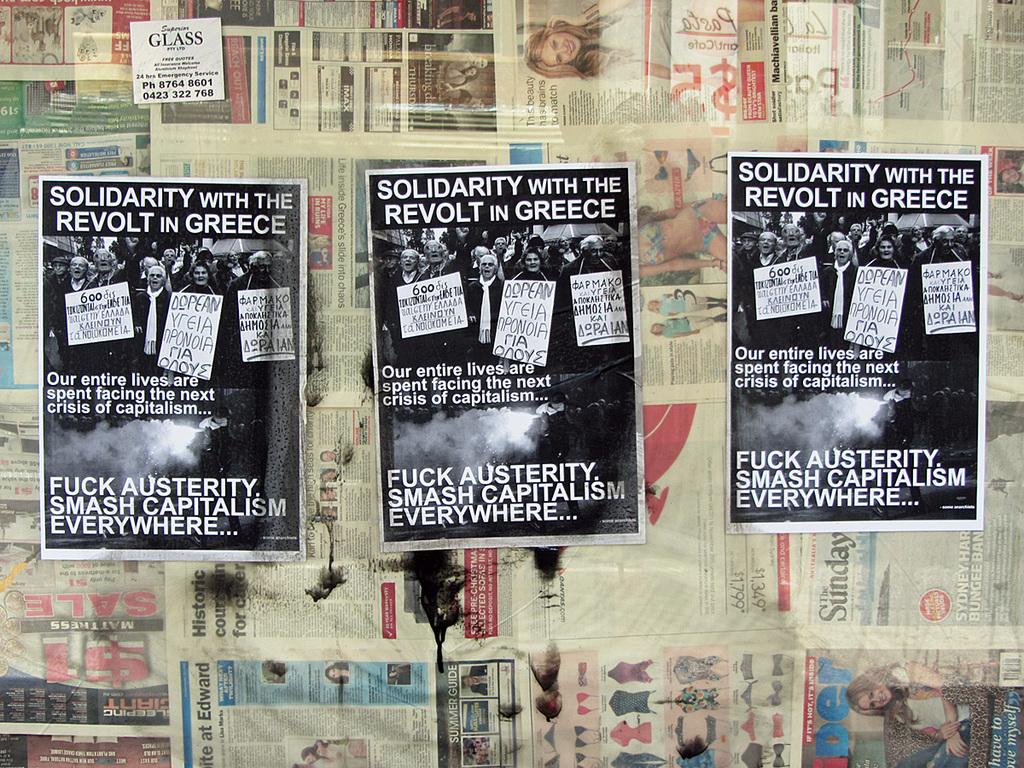What country is depicted in the poster?
Make the answer very short. Greece. Where is the revolt?
Your answer should be compact. Greece. 